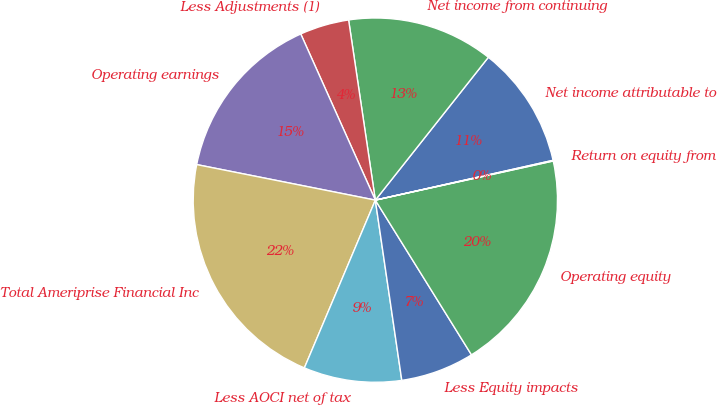Convert chart. <chart><loc_0><loc_0><loc_500><loc_500><pie_chart><fcel>Net income attributable to<fcel>Net income from continuing<fcel>Less Adjustments (1)<fcel>Operating earnings<fcel>Total Ameriprise Financial Inc<fcel>Less AOCI net of tax<fcel>Less Equity impacts<fcel>Operating equity<fcel>Return on equity from<nl><fcel>10.84%<fcel>13.0%<fcel>4.37%<fcel>15.16%<fcel>21.76%<fcel>8.69%<fcel>6.53%<fcel>19.6%<fcel>0.06%<nl></chart> 